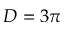Convert formula to latex. <formula><loc_0><loc_0><loc_500><loc_500>D = 3 \pi</formula> 